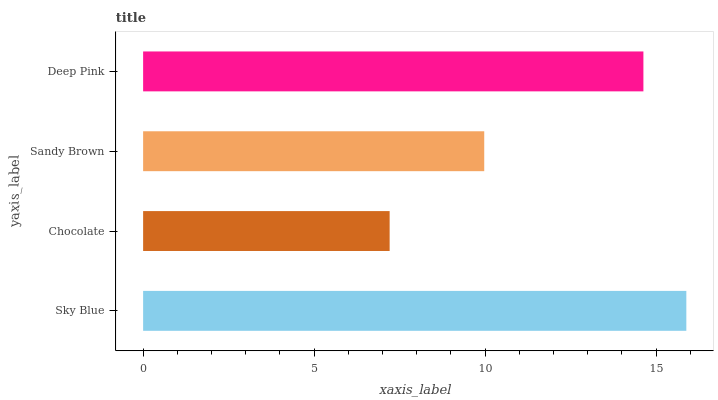Is Chocolate the minimum?
Answer yes or no. Yes. Is Sky Blue the maximum?
Answer yes or no. Yes. Is Sandy Brown the minimum?
Answer yes or no. No. Is Sandy Brown the maximum?
Answer yes or no. No. Is Sandy Brown greater than Chocolate?
Answer yes or no. Yes. Is Chocolate less than Sandy Brown?
Answer yes or no. Yes. Is Chocolate greater than Sandy Brown?
Answer yes or no. No. Is Sandy Brown less than Chocolate?
Answer yes or no. No. Is Deep Pink the high median?
Answer yes or no. Yes. Is Sandy Brown the low median?
Answer yes or no. Yes. Is Chocolate the high median?
Answer yes or no. No. Is Sky Blue the low median?
Answer yes or no. No. 